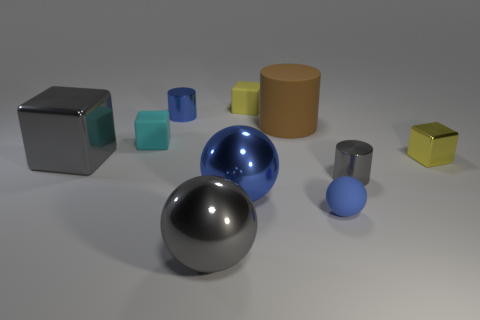What size is the blue metallic object that is on the right side of the gray ball?
Make the answer very short. Large. How many tiny objects are matte blocks or red metallic cubes?
Your response must be concise. 2. What is the color of the large shiny object that is behind the large gray ball and right of the cyan rubber thing?
Your answer should be very brief. Blue. Is there a tiny metallic thing that has the same shape as the large brown rubber thing?
Provide a short and direct response. Yes. What material is the small gray cylinder?
Offer a terse response. Metal. There is a small gray cylinder; are there any large matte things on the left side of it?
Offer a terse response. Yes. Is the shape of the small yellow rubber thing the same as the brown rubber object?
Make the answer very short. No. What number of other objects are there of the same size as the blue shiny sphere?
Give a very brief answer. 3. How many objects are large gray things to the right of the large shiny block or tiny shiny cylinders?
Your response must be concise. 3. The small ball has what color?
Your answer should be very brief. Blue. 